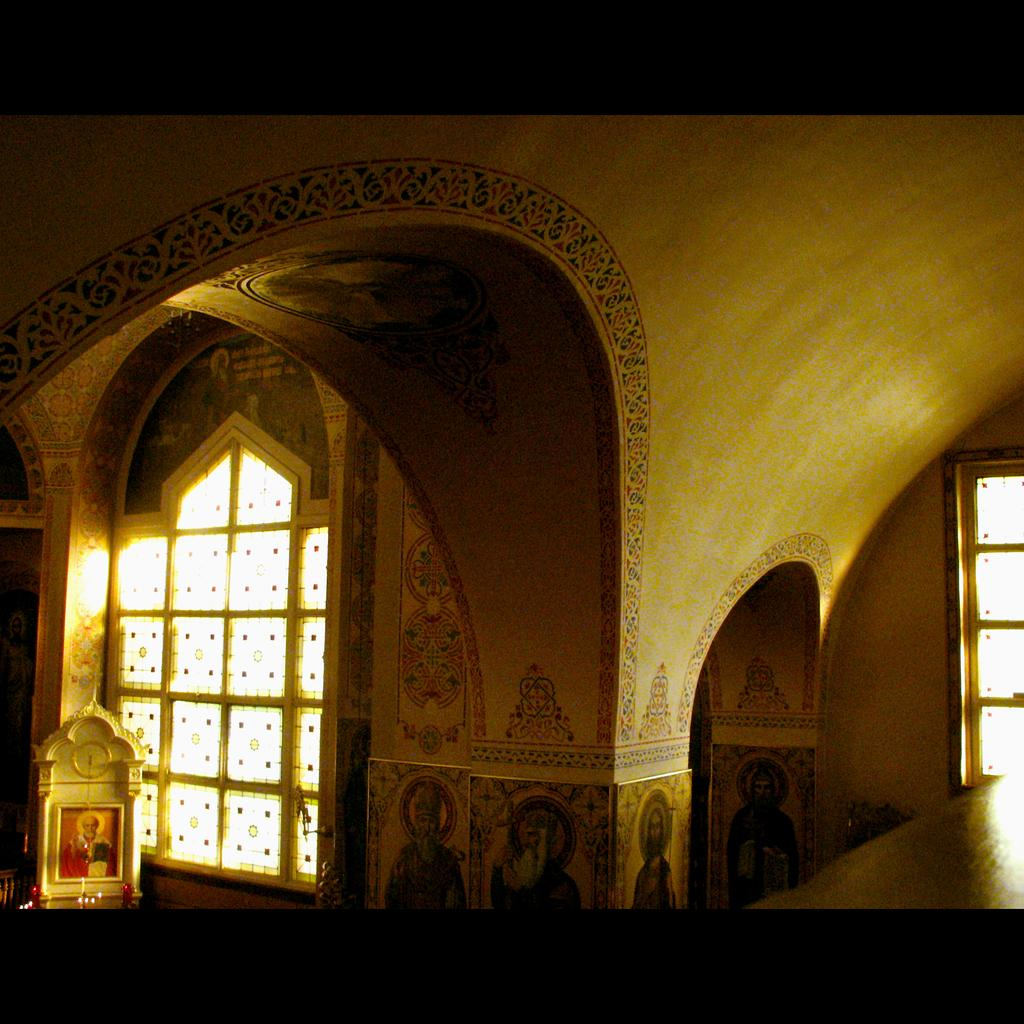How many windows can be seen in the image? There are two windows in the image. What architectural feature is present in the image? There are arches in the image. What type of decoration is on the wall in the image? There are paintings on the wall in the image. What color is the mitten hanging on the wall in the image? There is no mitten present in the image. What type of metal is used for the brass sculpture in the image? There is no brass sculpture present in the image. 